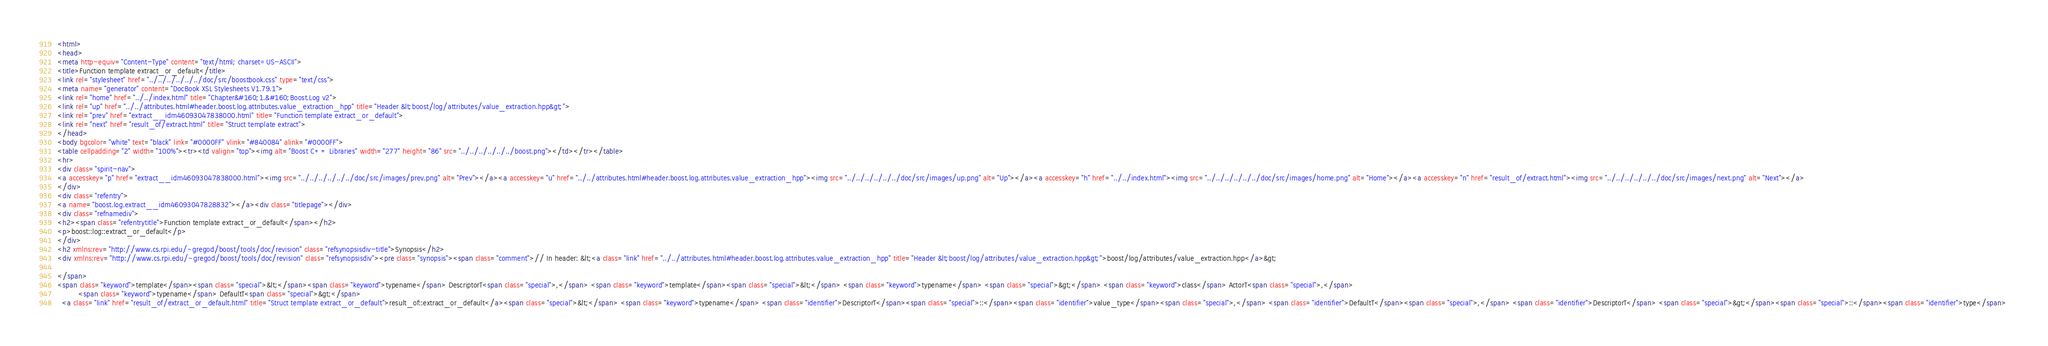<code> <loc_0><loc_0><loc_500><loc_500><_HTML_><html>
<head>
<meta http-equiv="Content-Type" content="text/html; charset=US-ASCII">
<title>Function template extract_or_default</title>
<link rel="stylesheet" href="../../../../../../doc/src/boostbook.css" type="text/css">
<meta name="generator" content="DocBook XSL Stylesheets V1.79.1">
<link rel="home" href="../../index.html" title="Chapter&#160;1.&#160;Boost.Log v2">
<link rel="up" href="../../attributes.html#header.boost.log.attributes.value_extraction_hpp" title="Header &lt;boost/log/attributes/value_extraction.hpp&gt;">
<link rel="prev" href="extract__idm46093047838000.html" title="Function template extract_or_default">
<link rel="next" href="result_of/extract.html" title="Struct template extract">
</head>
<body bgcolor="white" text="black" link="#0000FF" vlink="#840084" alink="#0000FF">
<table cellpadding="2" width="100%"><tr><td valign="top"><img alt="Boost C++ Libraries" width="277" height="86" src="../../../../../../boost.png"></td></tr></table>
<hr>
<div class="spirit-nav">
<a accesskey="p" href="extract__idm46093047838000.html"><img src="../../../../../../doc/src/images/prev.png" alt="Prev"></a><a accesskey="u" href="../../attributes.html#header.boost.log.attributes.value_extraction_hpp"><img src="../../../../../../doc/src/images/up.png" alt="Up"></a><a accesskey="h" href="../../index.html"><img src="../../../../../../doc/src/images/home.png" alt="Home"></a><a accesskey="n" href="result_of/extract.html"><img src="../../../../../../doc/src/images/next.png" alt="Next"></a>
</div>
<div class="refentry">
<a name="boost.log.extract__idm46093047828832"></a><div class="titlepage"></div>
<div class="refnamediv">
<h2><span class="refentrytitle">Function template extract_or_default</span></h2>
<p>boost::log::extract_or_default</p>
</div>
<h2 xmlns:rev="http://www.cs.rpi.edu/~gregod/boost/tools/doc/revision" class="refsynopsisdiv-title">Synopsis</h2>
<div xmlns:rev="http://www.cs.rpi.edu/~gregod/boost/tools/doc/revision" class="refsynopsisdiv"><pre class="synopsis"><span class="comment">// In header: &lt;<a class="link" href="../../attributes.html#header.boost.log.attributes.value_extraction_hpp" title="Header &lt;boost/log/attributes/value_extraction.hpp&gt;">boost/log/attributes/value_extraction.hpp</a>&gt;

</span>
<span class="keyword">template</span><span class="special">&lt;</span><span class="keyword">typename</span> DescriptorT<span class="special">,</span> <span class="keyword">template</span><span class="special">&lt;</span> <span class="keyword">typename</span> <span class="special">&gt;</span> <span class="keyword">class</span> ActorT<span class="special">,</span> 
         <span class="keyword">typename</span> DefaultT<span class="special">&gt;</span> 
  <a class="link" href="result_of/extract_or_default.html" title="Struct template extract_or_default">result_of::extract_or_default</a><span class="special">&lt;</span> <span class="keyword">typename</span> <span class="identifier">DescriptorT</span><span class="special">::</span><span class="identifier">value_type</span><span class="special">,</span> <span class="identifier">DefaultT</span><span class="special">,</span> <span class="identifier">DescriptorT</span> <span class="special">&gt;</span><span class="special">::</span><span class="identifier">type</span> </code> 